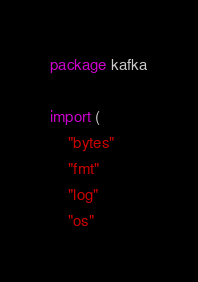<code> <loc_0><loc_0><loc_500><loc_500><_Go_>package kafka

import (
	"bytes"
	"fmt"
	"log"
	"os"</code> 